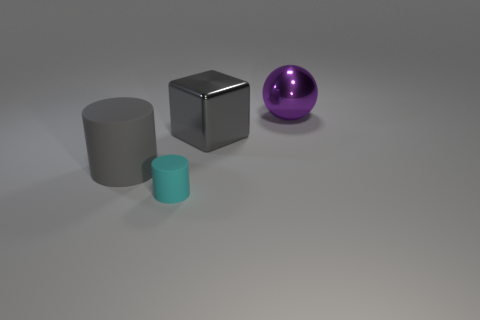Subtract 1 cylinders. How many cylinders are left? 1 Subtract all blue cylinders. How many cyan spheres are left? 0 Add 4 blue objects. How many objects exist? 8 Subtract all small yellow cylinders. Subtract all tiny cyan cylinders. How many objects are left? 3 Add 1 small things. How many small things are left? 2 Add 3 metallic balls. How many metallic balls exist? 4 Subtract 0 red cubes. How many objects are left? 4 Subtract all yellow cylinders. Subtract all green cubes. How many cylinders are left? 2 